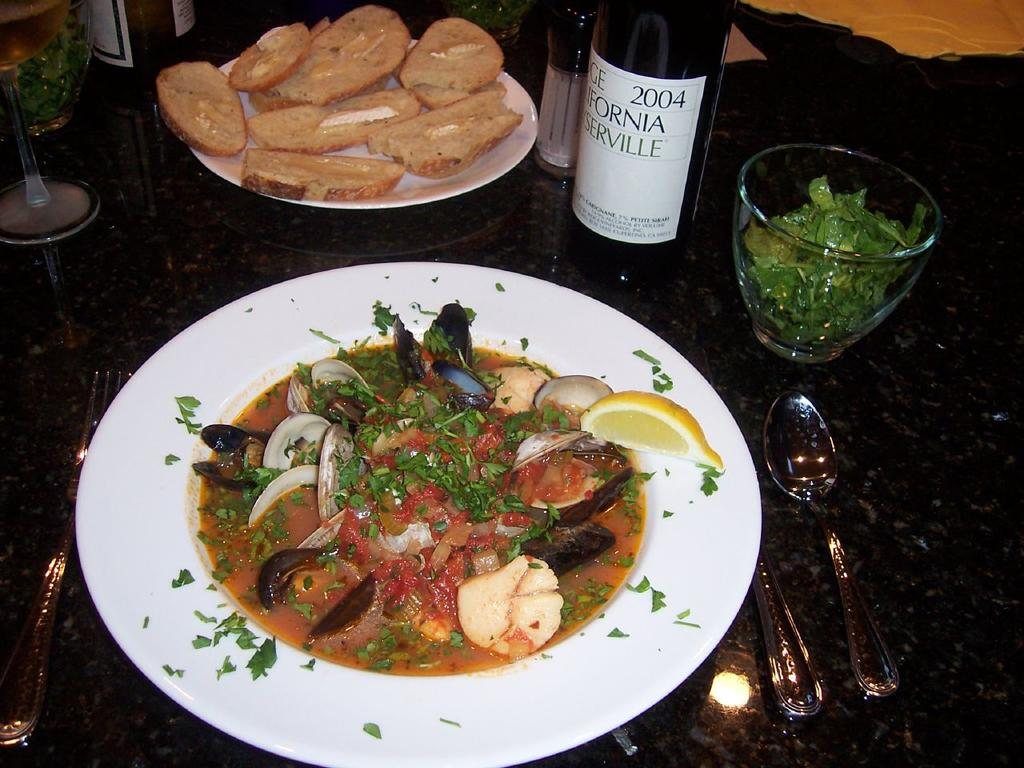What type of food is present in the image? There is food in plates in the image. What type of containers are present in the image? There are glasses and bottles in the image. What utensils can be seen in the image? A spoon and a fork are visible in the image. What type of engine is visible in the image? There is no engine present in the image. Can you describe the berries in the image? There are no berries present in the image. 